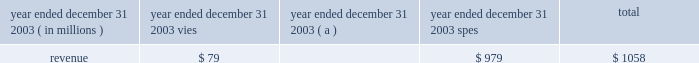J.p .
Morgan chase & co .
/ 2003 annual report 49 off 2013balance sheet arrangements and contractual cash obligations special-purpose entities special-purpose entities ( 201cspes 201d ) , special-purpose vehicles ( 201cspvs 201d ) , or variable-interest entities ( 201cvies 201d ) , are an important part of the financial markets , providing market liquidity by facili- tating investors 2019 access to specific portfolios of assets and risks .
Spes are not operating entities ; typically they are established for a single , discrete purpose , have a limited life and have no employees .
The basic spe structure involves a company selling assets to the spe .
The spe funds the asset purchase by selling securities to investors .
To insulate investors from creditors of other entities , including the seller of the assets , spes are often structured to be bankruptcy-remote .
Spes are critical to the functioning of many investor markets , including , for example , the market for mortgage-backed securities , other asset-backed securities and commercial paper .
Jpmorgan chase is involved with spes in three broad categories of transactions : loan securi- tizations ( through 201cqualifying 201d spes ) , multi-seller conduits , and client intermediation .
Capital is held , as appropriate , against all spe-related transactions and related exposures such as deriva- tive transactions and lending-related commitments .
The firm has no commitments to issue its own stock to support any spe transaction , and its policies require that transactions with spes be conducted at arm 2019s length and reflect market pric- ing .
Consistent with this policy , no jpmorgan chase employee is permitted to invest in spes with which the firm is involved where such investment would violate the firm 2019s worldwide rules of conduct .
These rules prohibit employees from self- dealing and prohibit employees from acting on behalf of the firm in transactions with which they or their family have any significant financial interest .
For certain liquidity commitments to spes , the firm could be required to provide funding if the credit rating of jpmorgan chase bank were downgraded below specific levels , primarily p-1 , a-1 and f1 for moody 2019s , standard & poor 2019s and fitch , respectively .
The amount of these liquidity commitments was $ 34.0 billion at december 31 , 2003 .
If jpmorgan chase bank were required to provide funding under these commitments , the firm could be replaced as liquidity provider .
Additionally , with respect to the multi-seller conduits and structured commercial loan vehicles for which jpmorgan chase bank has extended liq- uidity commitments , the bank could facilitate the sale or refi- nancing of the assets in the spe in order to provide liquidity .
Of these liquidity commitments to spes , $ 27.7 billion is included in the firm 2019s total other unfunded commitments to extend credit included in the table on the following page .
As a result of the consolidation of multi-seller conduits in accordance with fin 46 , $ 6.3 billion of these commitments are excluded from the table , as the underlying assets of the spe have been included on the firm 2019s consolidated balance sheet .
The table summarizes certain revenue information related to vies with which the firm has significant involvement , and qualifying spes: .
( a ) includes consolidated and nonconsolidated asset-backed commercial paper conduits for a consistent presentation of 2003 results .
The revenue reported in the table above represents primarily servicing fee income .
The firm also has exposure to certain vie vehicles arising from derivative transactions with vies ; these transactions are recorded at fair value on the firm 2019s consolidated balance sheet with changes in fair value ( i.e. , mark-to-market gains and losses ) recorded in trading revenue .
Such mtm gains and losses are not included in the revenue amounts reported in the table above .
For a further discussion of spes and the firm 2019s accounting for spes , see note 1 on pages 86 201387 , note 13 on pages 100 2013103 , and note 14 on pages 103 2013106 of this annual report .
Contractual cash obligations in the normal course of business , the firm enters into various con- tractual obligations that may require future cash payments .
Contractual obligations at december 31 , 2003 , include long-term debt , trust preferred capital securities , operating leases , contractual purchases and capital expenditures and certain other liabilities .
For a further discussion regarding long-term debt and trust preferred capital securities , see note 18 on pages 109 2013111 of this annual report .
For a further discussion regarding operating leases , see note 27 on page 115 of this annual report .
The accompanying table summarizes jpmorgan chase 2019s off 2013 balance sheet lending-related financial instruments and signifi- cant contractual cash obligations , by remaining maturity , at december 31 , 2003 .
Contractual purchases include commit- ments for future cash expenditures , primarily for services and contracts involving certain forward purchases of securities and commodities .
Capital expenditures primarily represent future cash payments for real estate 2013related obligations and equip- ment .
Contractual purchases and capital expenditures at december 31 , 2003 , reflect the minimum contractual obligation under legally enforceable contracts with contract terms that are both fixed and determinable .
Excluded from the following table are a number of obligations to be settled in cash , primarily in under one year .
These obligations are reflected on the firm 2019s consolidated balance sheet and include deposits ; federal funds purchased and securities sold under repurchase agreements ; other borrowed funds ; purchases of debt and equity instruments that settle within standard market timeframes ( e.g .
Regular-way ) ; derivative payables that do not require physical delivery of the underlying instrument ; and certain purchases of instruments that resulted in settlement failures. .
In 2003 what was the percent of the total revenues from vies? 
Computations: (79 / 1058)
Answer: 0.07467. 